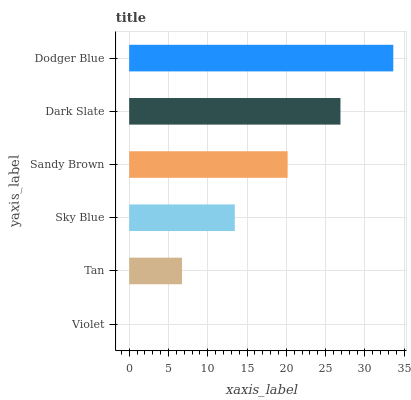Is Violet the minimum?
Answer yes or no. Yes. Is Dodger Blue the maximum?
Answer yes or no. Yes. Is Tan the minimum?
Answer yes or no. No. Is Tan the maximum?
Answer yes or no. No. Is Tan greater than Violet?
Answer yes or no. Yes. Is Violet less than Tan?
Answer yes or no. Yes. Is Violet greater than Tan?
Answer yes or no. No. Is Tan less than Violet?
Answer yes or no. No. Is Sandy Brown the high median?
Answer yes or no. Yes. Is Sky Blue the low median?
Answer yes or no. Yes. Is Dark Slate the high median?
Answer yes or no. No. Is Dark Slate the low median?
Answer yes or no. No. 